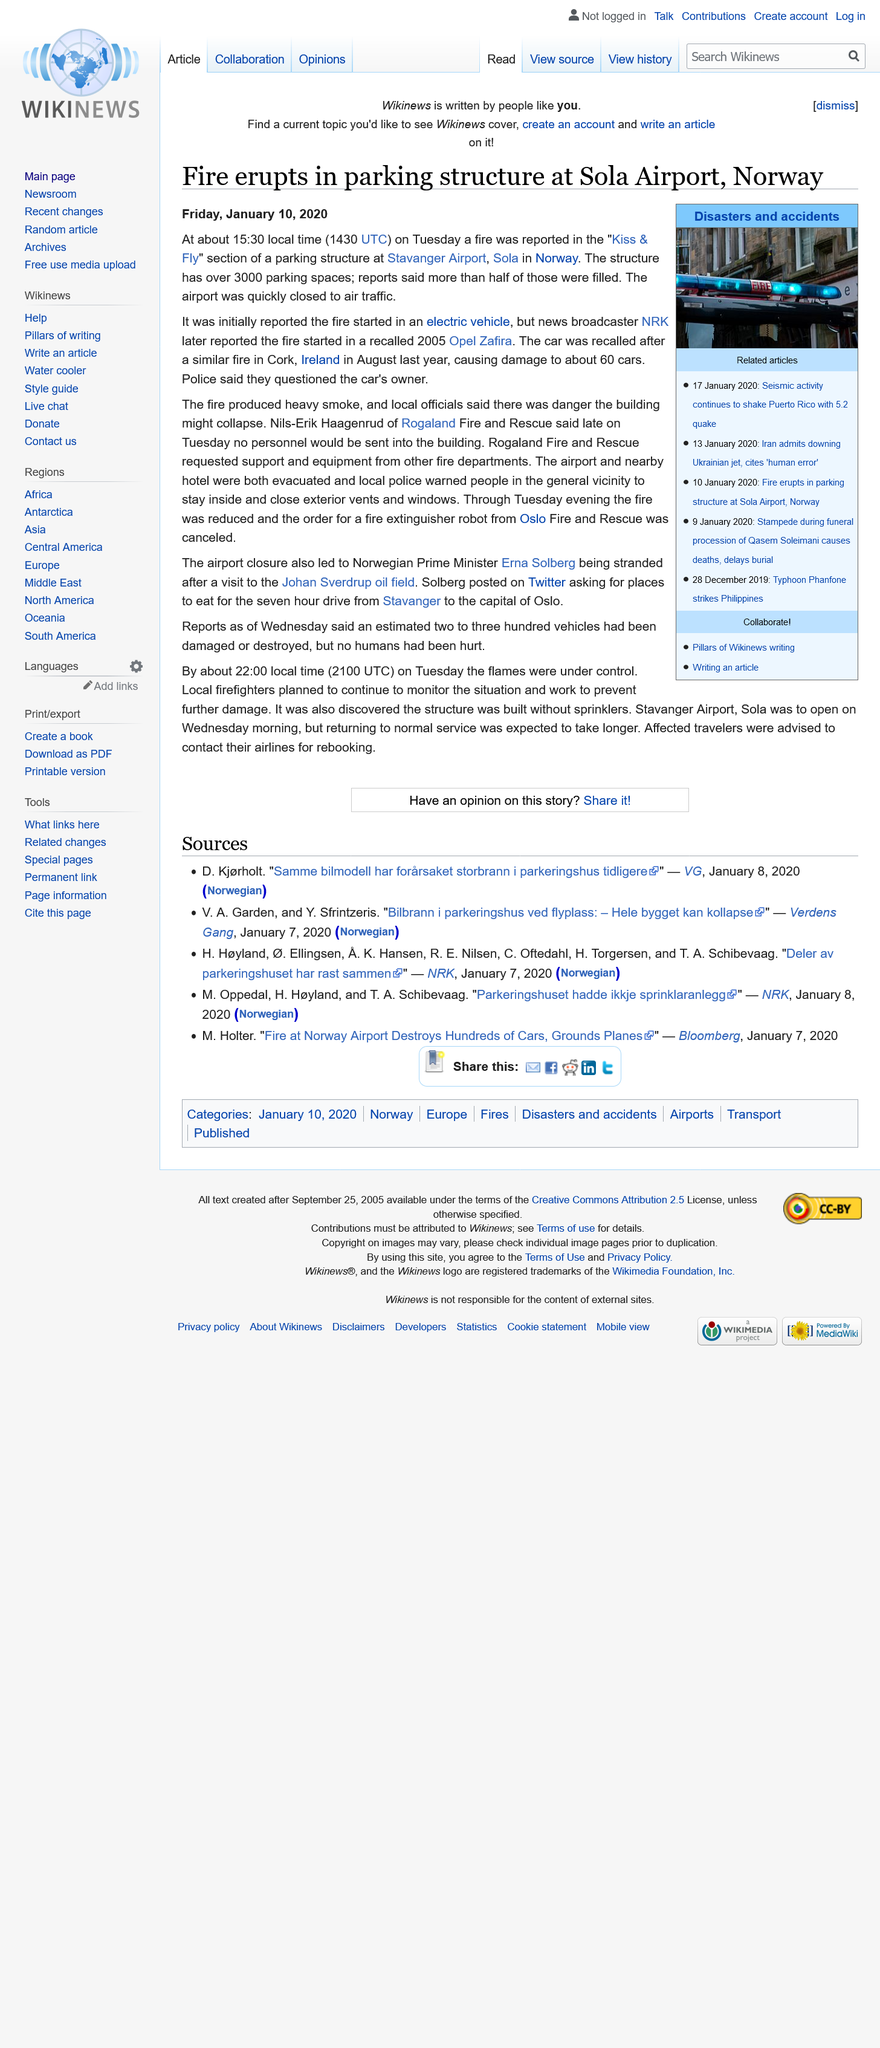Specify some key components in this picture. The fire at Stavanger Airport produced heavy smoke. The incident occurred in Norway, as stated in the report. The article was published on October 1, 2020. 